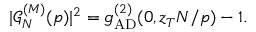Convert formula to latex. <formula><loc_0><loc_0><loc_500><loc_500>| \mathcal { G } _ { N } ^ { ( M ) } ( p ) | ^ { 2 } = g _ { A D } ^ { ( 2 ) } ( 0 , z _ { T } N / p ) - 1 .</formula> 